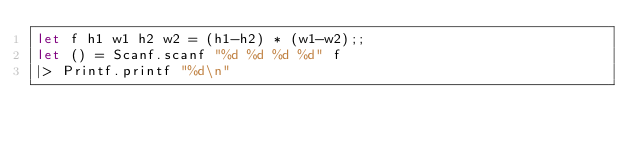<code> <loc_0><loc_0><loc_500><loc_500><_OCaml_>let f h1 w1 h2 w2 = (h1-h2) * (w1-w2);;
let () = Scanf.scanf "%d %d %d %d" f
|> Printf.printf "%d\n"</code> 